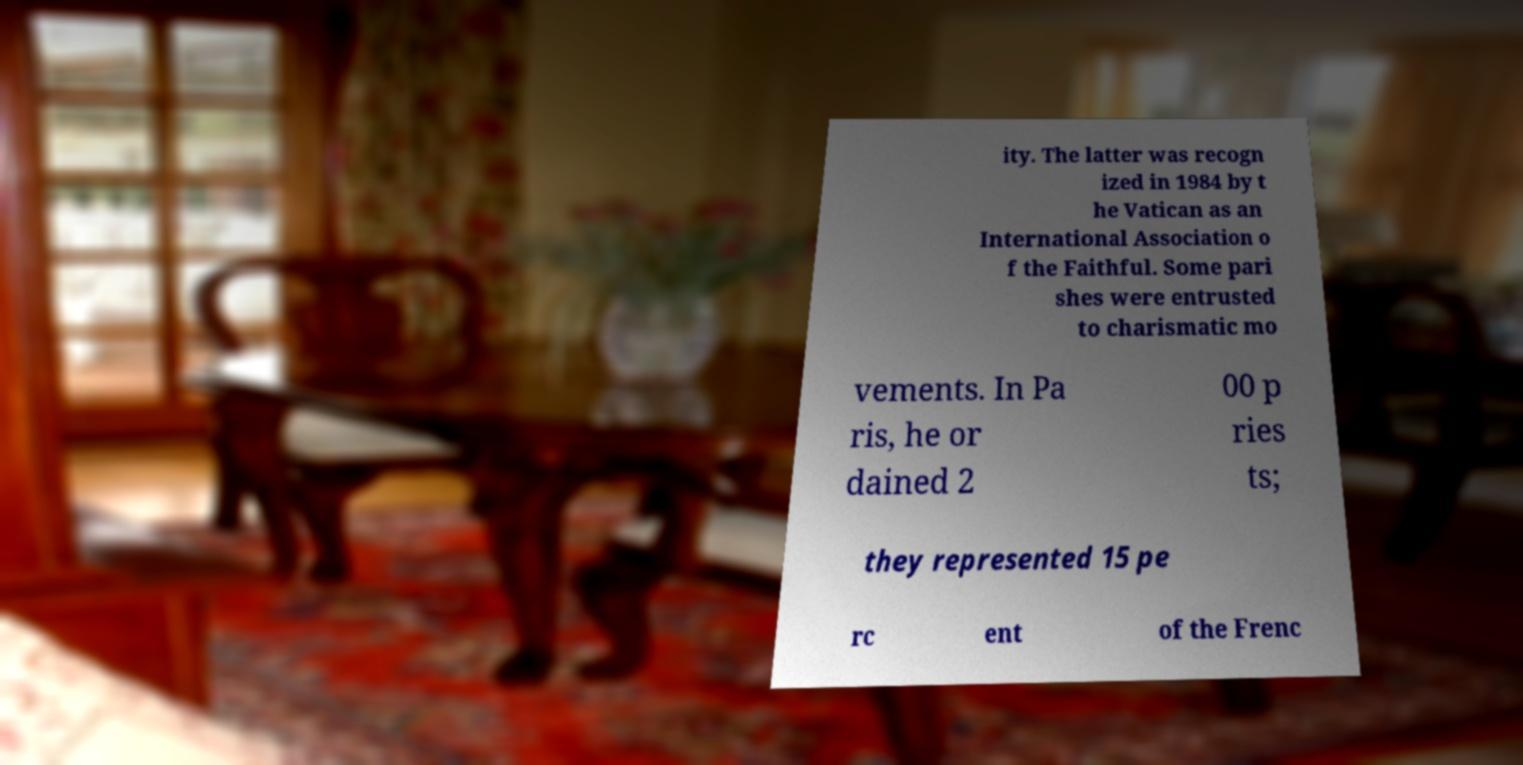For documentation purposes, I need the text within this image transcribed. Could you provide that? ity. The latter was recogn ized in 1984 by t he Vatican as an International Association o f the Faithful. Some pari shes were entrusted to charismatic mo vements. In Pa ris, he or dained 2 00 p ries ts; they represented 15 pe rc ent of the Frenc 